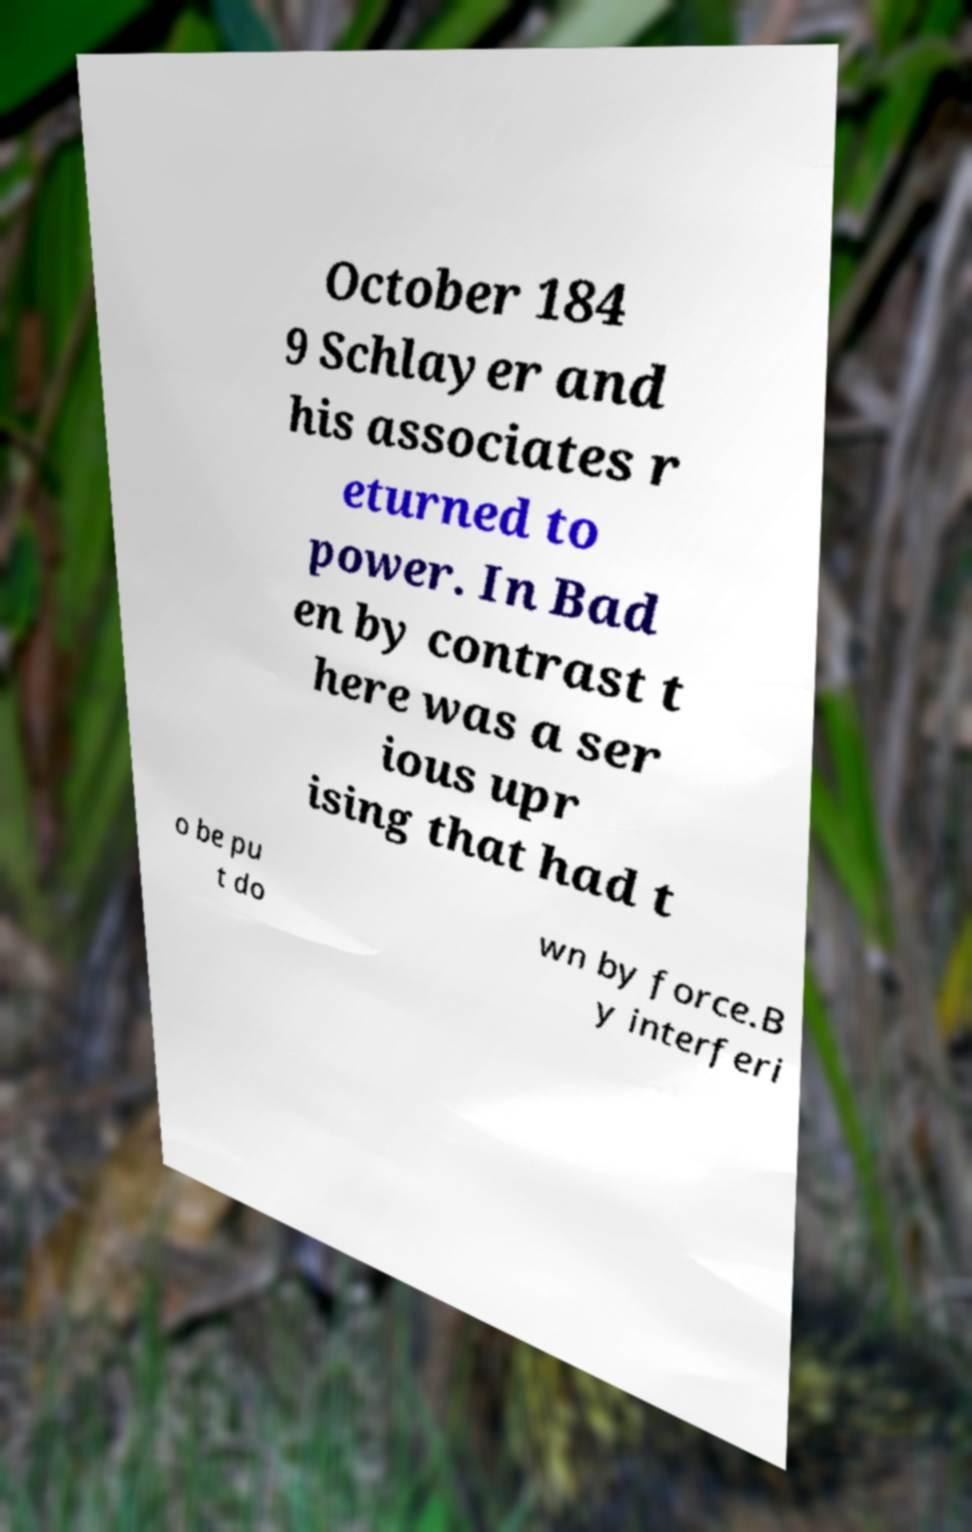Please identify and transcribe the text found in this image. October 184 9 Schlayer and his associates r eturned to power. In Bad en by contrast t here was a ser ious upr ising that had t o be pu t do wn by force.B y interferi 